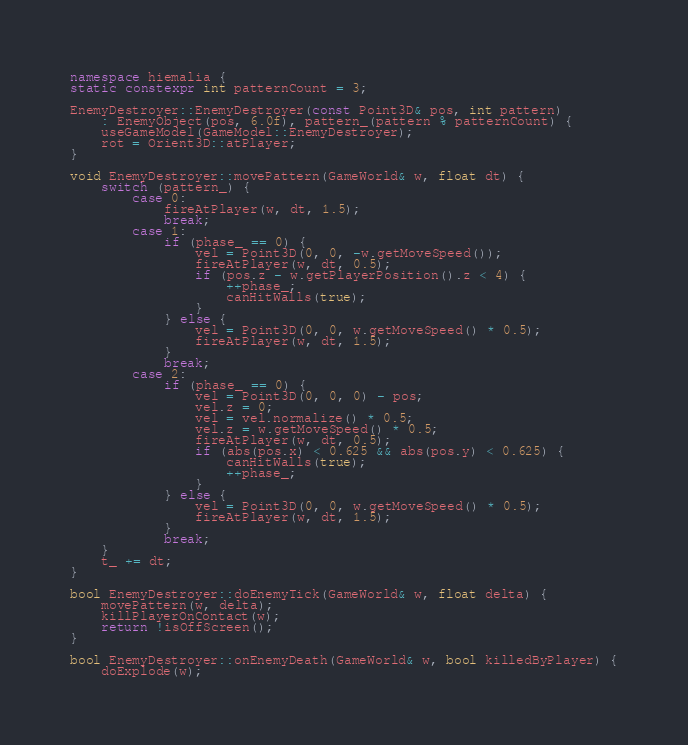Convert code to text. <code><loc_0><loc_0><loc_500><loc_500><_C++_>
namespace hiemalia {
static constexpr int patternCount = 3;

EnemyDestroyer::EnemyDestroyer(const Point3D& pos, int pattern)
    : EnemyObject(pos, 6.0f), pattern_(pattern % patternCount) {
    useGameModel(GameModel::EnemyDestroyer);
    rot = Orient3D::atPlayer;
}

void EnemyDestroyer::movePattern(GameWorld& w, float dt) {
    switch (pattern_) {
        case 0:
            fireAtPlayer(w, dt, 1.5);
            break;
        case 1:
            if (phase_ == 0) {
                vel = Point3D(0, 0, -w.getMoveSpeed());
                fireAtPlayer(w, dt, 0.5);
                if (pos.z - w.getPlayerPosition().z < 4) {
                    ++phase_;
                    canHitWalls(true);
                }
            } else {
                vel = Point3D(0, 0, w.getMoveSpeed() * 0.5);
                fireAtPlayer(w, dt, 1.5);
            }
            break;
        case 2:
            if (phase_ == 0) {
                vel = Point3D(0, 0, 0) - pos;
                vel.z = 0;
                vel = vel.normalize() * 0.5;
                vel.z = w.getMoveSpeed() * 0.5;
                fireAtPlayer(w, dt, 0.5);
                if (abs(pos.x) < 0.625 && abs(pos.y) < 0.625) {
                    canHitWalls(true);
                    ++phase_;
                }
            } else {
                vel = Point3D(0, 0, w.getMoveSpeed() * 0.5);
                fireAtPlayer(w, dt, 1.5);
            }
            break;
    }
    t_ += dt;
}

bool EnemyDestroyer::doEnemyTick(GameWorld& w, float delta) {
    movePattern(w, delta);
    killPlayerOnContact(w);
    return !isOffScreen();
}

bool EnemyDestroyer::onEnemyDeath(GameWorld& w, bool killedByPlayer) {
    doExplode(w);</code> 